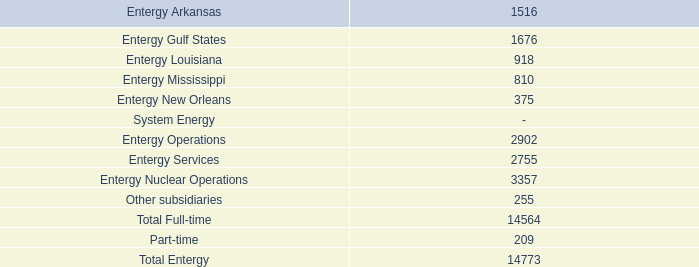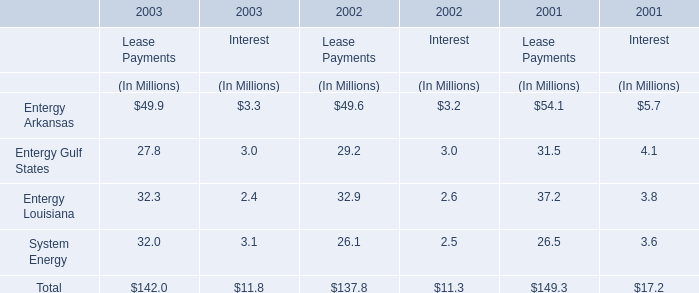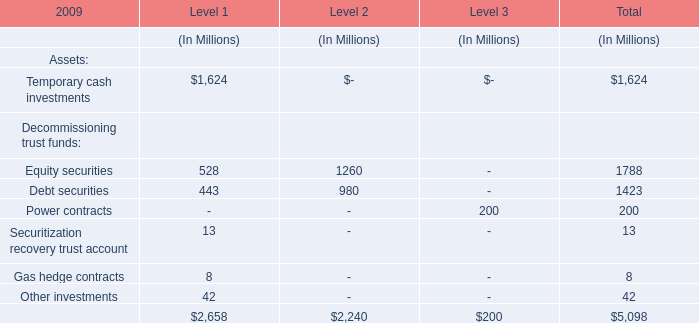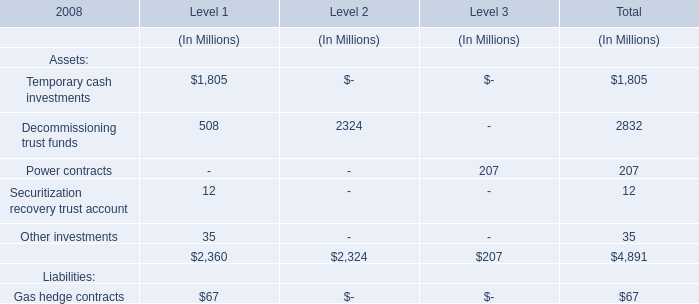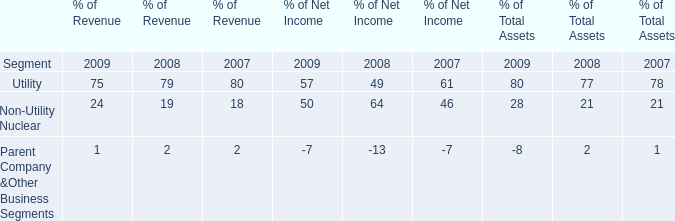what is the highest total amount of Level 1? (in million) 
Answer: 1805.0. 